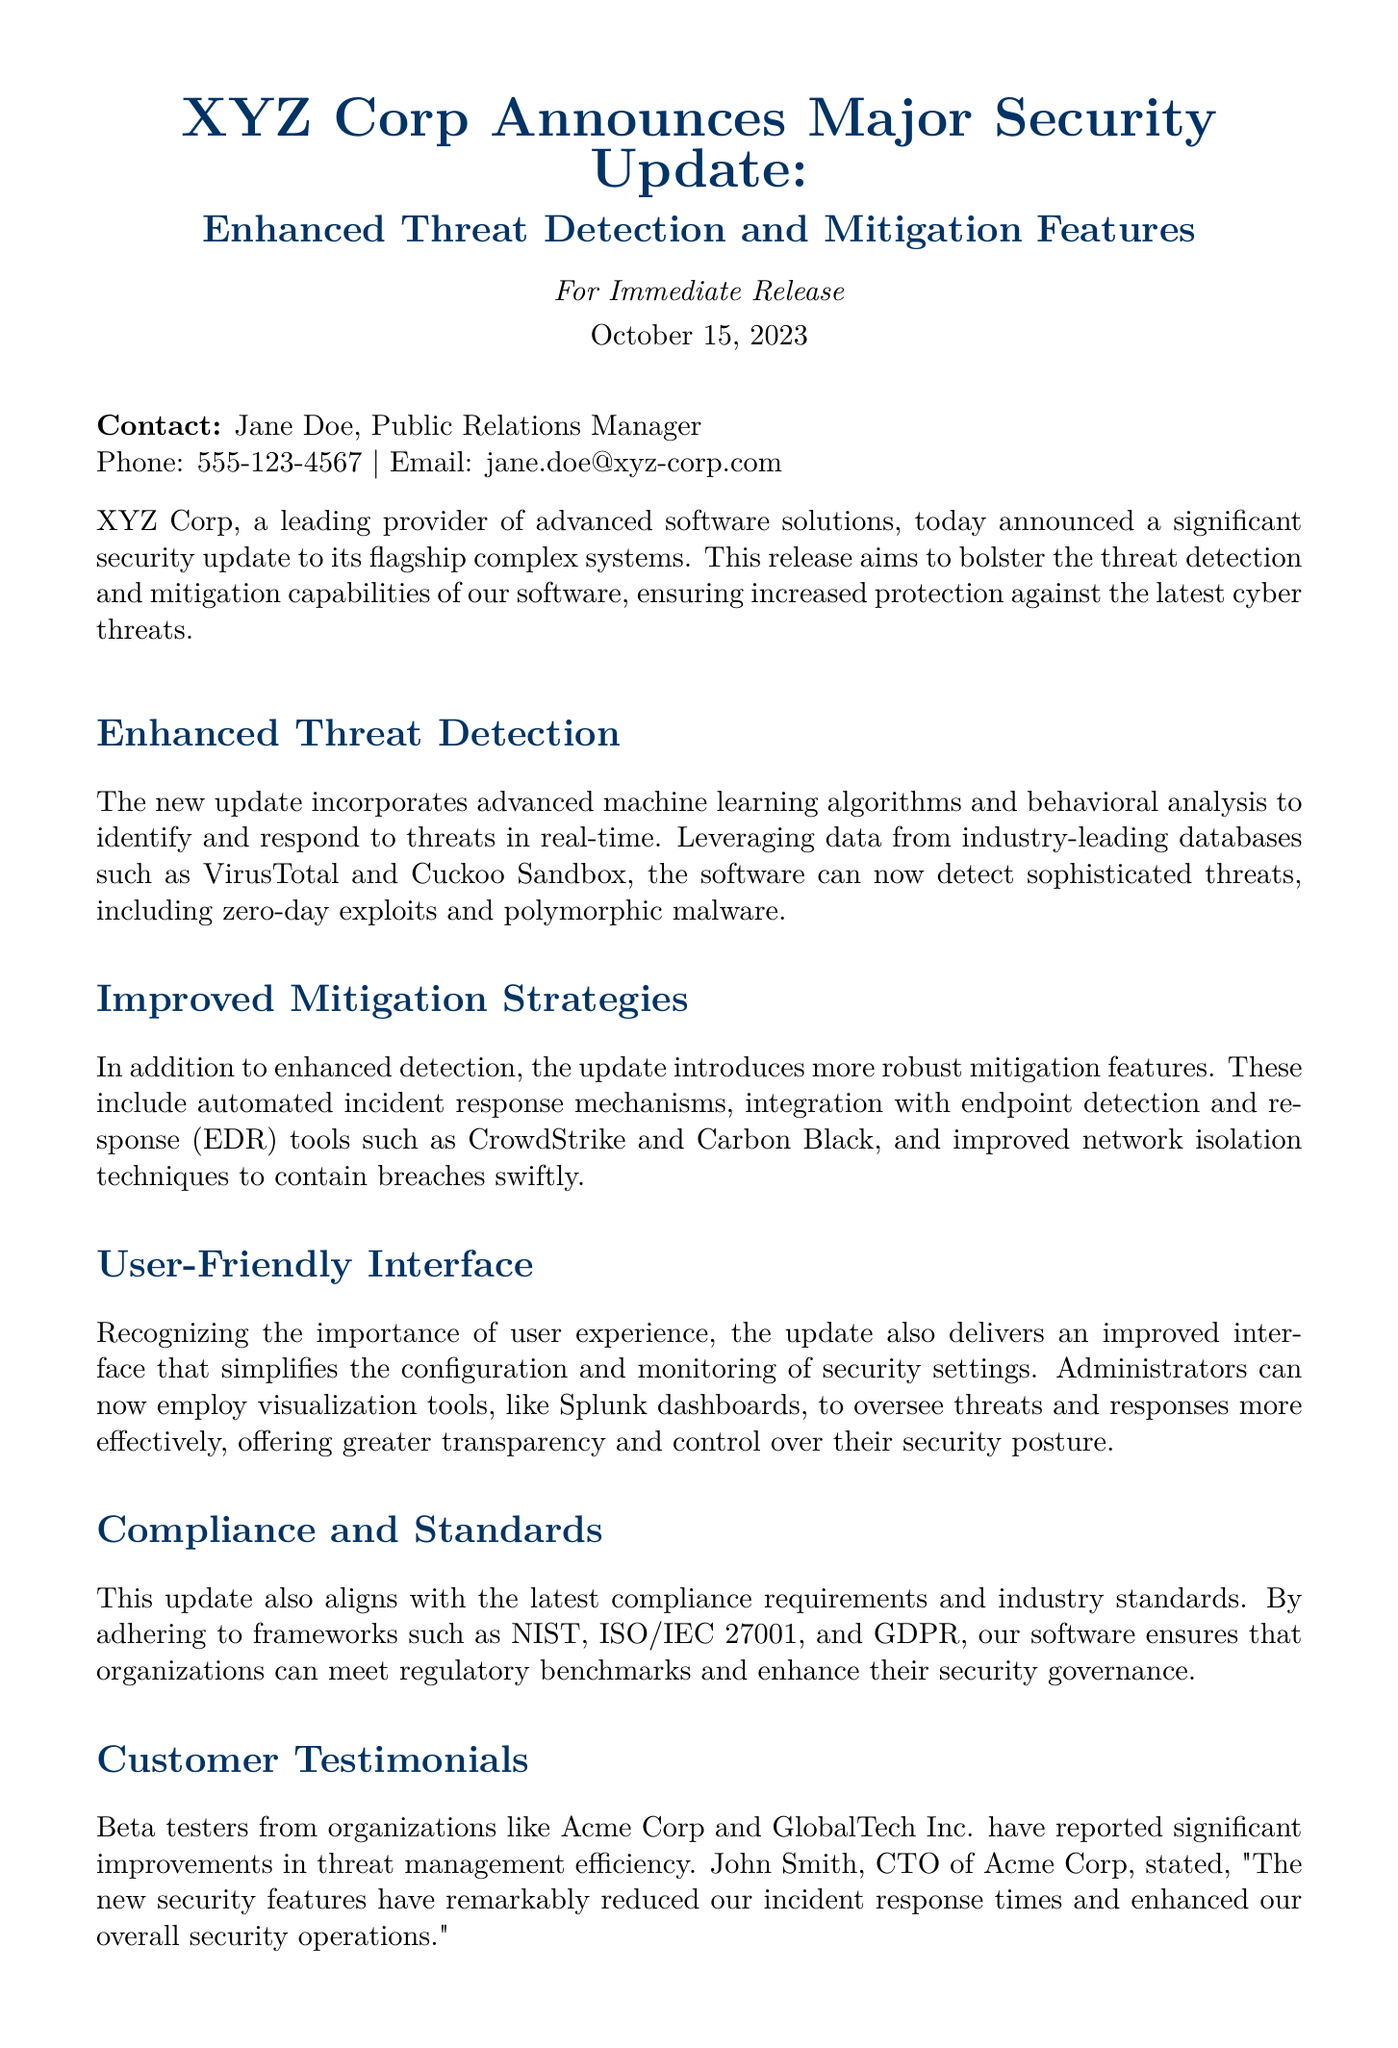What is the date of the press release? The date of the press release is mentioned in the header section of the document.
Answer: October 15, 2023 Who is the Public Relations Manager? The contact information provided includes the name of the Public Relations Manager.
Answer: Jane Doe What advanced technology is used for threat detection? The section discussing enhanced threat detection highlights the technology used.
Answer: Machine learning algorithms Which two EDR tools are integrated with the new update? The document lists the endpoint detection and response tools included in the update.
Answer: CrowdStrike and Carbon Black What organizations reported improvements in threat management? The customer testimonials section names organizations that beta tested the updates.
Answer: Acme Corp and GlobalTech Inc What is the main goal of the security update? The first paragraph states the primary objective of the update.
Answer: Increase protection against cyber threats Which compliance frameworks does the update adhere to? The document mentions specific compliance standards in one of the sections.
Answer: NIST, ISO/IEC 27001, and GDPR What type of interface improvements were made? The user-friendly interface section describes the improvements made to the software.
Answer: Simplified configuration and monitoring What is a key benefit mentioned by John Smith from Acme Corp? The customer testimonials section includes a direct quote mentioning benefits.
Answer: Reduced incident response times 